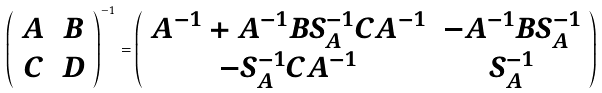Convert formula to latex. <formula><loc_0><loc_0><loc_500><loc_500>\left ( \begin{array} { c c } A & B \\ C & D \end{array} \right ) ^ { - 1 } = \left ( \begin{array} { c c } A ^ { - 1 } + A ^ { - 1 } B S ^ { - 1 } _ { A } C A ^ { - 1 } & - A ^ { - 1 } B S ^ { - 1 } _ { A } \\ - S ^ { - 1 } _ { A } C A ^ { - 1 } & S ^ { - 1 } _ { A } \end{array} \right )</formula> 